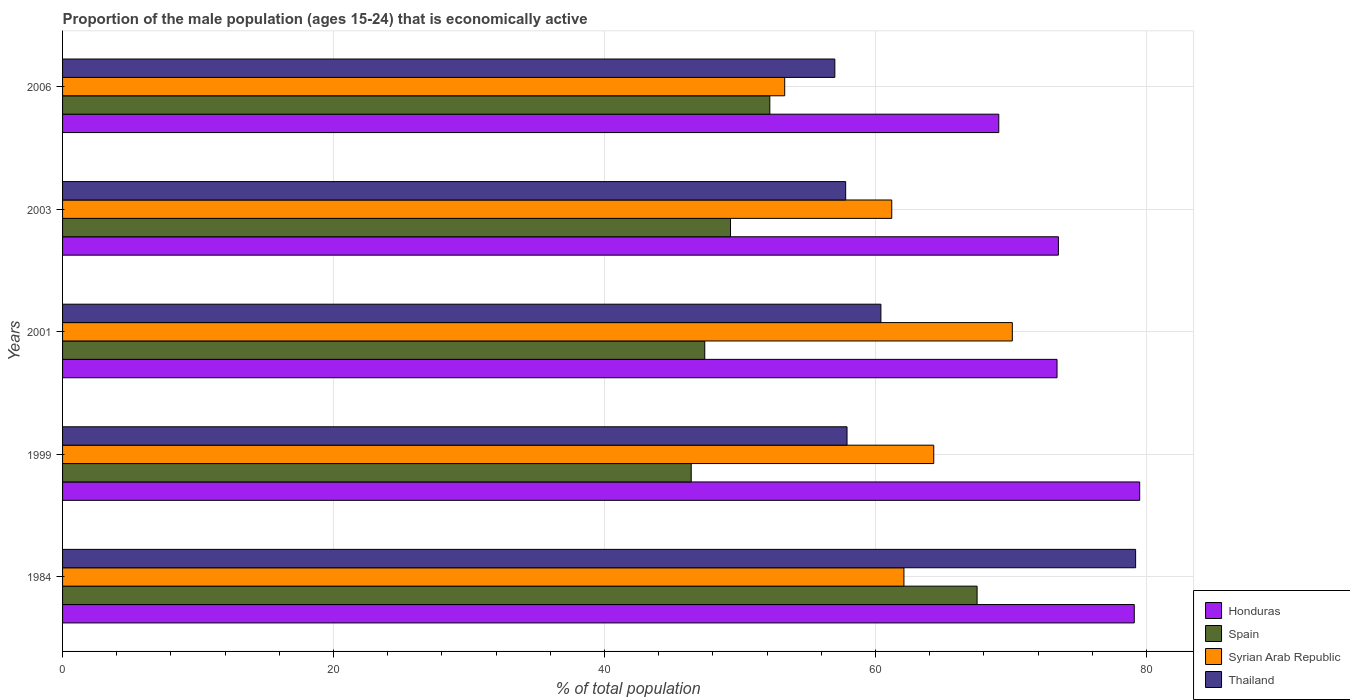Are the number of bars on each tick of the Y-axis equal?
Your response must be concise. Yes. How many bars are there on the 5th tick from the top?
Ensure brevity in your answer.  4. How many bars are there on the 2nd tick from the bottom?
Make the answer very short. 4. What is the label of the 4th group of bars from the top?
Offer a very short reply. 1999. What is the proportion of the male population that is economically active in Spain in 2006?
Ensure brevity in your answer.  52.2. Across all years, what is the maximum proportion of the male population that is economically active in Syrian Arab Republic?
Offer a terse response. 70.1. Across all years, what is the minimum proportion of the male population that is economically active in Honduras?
Offer a terse response. 69.1. What is the total proportion of the male population that is economically active in Honduras in the graph?
Offer a terse response. 374.6. What is the difference between the proportion of the male population that is economically active in Thailand in 2003 and that in 2006?
Keep it short and to the point. 0.8. What is the difference between the proportion of the male population that is economically active in Thailand in 2001 and the proportion of the male population that is economically active in Honduras in 1984?
Provide a succinct answer. -18.7. What is the average proportion of the male population that is economically active in Syrian Arab Republic per year?
Provide a succinct answer. 62.2. In the year 1999, what is the difference between the proportion of the male population that is economically active in Honduras and proportion of the male population that is economically active in Syrian Arab Republic?
Your answer should be very brief. 15.2. In how many years, is the proportion of the male population that is economically active in Honduras greater than 52 %?
Provide a short and direct response. 5. What is the ratio of the proportion of the male population that is economically active in Thailand in 1984 to that in 2006?
Provide a succinct answer. 1.39. Is the proportion of the male population that is economically active in Spain in 1999 less than that in 2001?
Provide a short and direct response. Yes. Is the difference between the proportion of the male population that is economically active in Honduras in 1999 and 2001 greater than the difference between the proportion of the male population that is economically active in Syrian Arab Republic in 1999 and 2001?
Provide a succinct answer. Yes. What is the difference between the highest and the second highest proportion of the male population that is economically active in Spain?
Your response must be concise. 15.3. What is the difference between the highest and the lowest proportion of the male population that is economically active in Honduras?
Your answer should be compact. 10.4. In how many years, is the proportion of the male population that is economically active in Spain greater than the average proportion of the male population that is economically active in Spain taken over all years?
Give a very brief answer. 1. Is the sum of the proportion of the male population that is economically active in Thailand in 1984 and 2001 greater than the maximum proportion of the male population that is economically active in Honduras across all years?
Keep it short and to the point. Yes. Is it the case that in every year, the sum of the proportion of the male population that is economically active in Thailand and proportion of the male population that is economically active in Syrian Arab Republic is greater than the sum of proportion of the male population that is economically active in Spain and proportion of the male population that is economically active in Honduras?
Your answer should be very brief. No. What does the 4th bar from the top in 1999 represents?
Your response must be concise. Honduras. What does the 2nd bar from the bottom in 1999 represents?
Your answer should be very brief. Spain. Is it the case that in every year, the sum of the proportion of the male population that is economically active in Honduras and proportion of the male population that is economically active in Spain is greater than the proportion of the male population that is economically active in Thailand?
Make the answer very short. Yes. How many bars are there?
Provide a short and direct response. 20. How many years are there in the graph?
Make the answer very short. 5. What is the difference between two consecutive major ticks on the X-axis?
Your response must be concise. 20. Are the values on the major ticks of X-axis written in scientific E-notation?
Your response must be concise. No. Does the graph contain any zero values?
Your response must be concise. No. Where does the legend appear in the graph?
Your answer should be compact. Bottom right. How are the legend labels stacked?
Provide a short and direct response. Vertical. What is the title of the graph?
Make the answer very short. Proportion of the male population (ages 15-24) that is economically active. What is the label or title of the X-axis?
Your answer should be compact. % of total population. What is the label or title of the Y-axis?
Offer a terse response. Years. What is the % of total population in Honduras in 1984?
Keep it short and to the point. 79.1. What is the % of total population in Spain in 1984?
Ensure brevity in your answer.  67.5. What is the % of total population in Syrian Arab Republic in 1984?
Your answer should be very brief. 62.1. What is the % of total population of Thailand in 1984?
Your response must be concise. 79.2. What is the % of total population of Honduras in 1999?
Make the answer very short. 79.5. What is the % of total population of Spain in 1999?
Make the answer very short. 46.4. What is the % of total population of Syrian Arab Republic in 1999?
Provide a short and direct response. 64.3. What is the % of total population in Thailand in 1999?
Provide a succinct answer. 57.9. What is the % of total population in Honduras in 2001?
Your response must be concise. 73.4. What is the % of total population in Spain in 2001?
Your answer should be very brief. 47.4. What is the % of total population in Syrian Arab Republic in 2001?
Make the answer very short. 70.1. What is the % of total population in Thailand in 2001?
Make the answer very short. 60.4. What is the % of total population of Honduras in 2003?
Offer a very short reply. 73.5. What is the % of total population in Spain in 2003?
Offer a very short reply. 49.3. What is the % of total population in Syrian Arab Republic in 2003?
Keep it short and to the point. 61.2. What is the % of total population of Thailand in 2003?
Your answer should be compact. 57.8. What is the % of total population of Honduras in 2006?
Your answer should be very brief. 69.1. What is the % of total population of Spain in 2006?
Ensure brevity in your answer.  52.2. What is the % of total population of Syrian Arab Republic in 2006?
Give a very brief answer. 53.3. Across all years, what is the maximum % of total population of Honduras?
Your response must be concise. 79.5. Across all years, what is the maximum % of total population in Spain?
Make the answer very short. 67.5. Across all years, what is the maximum % of total population in Syrian Arab Republic?
Offer a very short reply. 70.1. Across all years, what is the maximum % of total population of Thailand?
Provide a short and direct response. 79.2. Across all years, what is the minimum % of total population in Honduras?
Make the answer very short. 69.1. Across all years, what is the minimum % of total population in Spain?
Your response must be concise. 46.4. Across all years, what is the minimum % of total population in Syrian Arab Republic?
Offer a terse response. 53.3. Across all years, what is the minimum % of total population in Thailand?
Provide a succinct answer. 57. What is the total % of total population in Honduras in the graph?
Your response must be concise. 374.6. What is the total % of total population of Spain in the graph?
Keep it short and to the point. 262.8. What is the total % of total population of Syrian Arab Republic in the graph?
Provide a succinct answer. 311. What is the total % of total population in Thailand in the graph?
Provide a short and direct response. 312.3. What is the difference between the % of total population in Spain in 1984 and that in 1999?
Offer a very short reply. 21.1. What is the difference between the % of total population in Thailand in 1984 and that in 1999?
Offer a terse response. 21.3. What is the difference between the % of total population in Honduras in 1984 and that in 2001?
Provide a short and direct response. 5.7. What is the difference between the % of total population in Spain in 1984 and that in 2001?
Offer a very short reply. 20.1. What is the difference between the % of total population of Syrian Arab Republic in 1984 and that in 2001?
Provide a short and direct response. -8. What is the difference between the % of total population in Thailand in 1984 and that in 2001?
Your answer should be very brief. 18.8. What is the difference between the % of total population of Thailand in 1984 and that in 2003?
Your answer should be compact. 21.4. What is the difference between the % of total population in Honduras in 1984 and that in 2006?
Your answer should be compact. 10. What is the difference between the % of total population of Spain in 1984 and that in 2006?
Your answer should be compact. 15.3. What is the difference between the % of total population of Syrian Arab Republic in 1984 and that in 2006?
Your answer should be very brief. 8.8. What is the difference between the % of total population of Thailand in 1984 and that in 2006?
Your answer should be compact. 22.2. What is the difference between the % of total population of Syrian Arab Republic in 1999 and that in 2001?
Provide a succinct answer. -5.8. What is the difference between the % of total population of Honduras in 1999 and that in 2003?
Offer a very short reply. 6. What is the difference between the % of total population in Spain in 1999 and that in 2003?
Your answer should be very brief. -2.9. What is the difference between the % of total population of Honduras in 1999 and that in 2006?
Provide a short and direct response. 10.4. What is the difference between the % of total population in Syrian Arab Republic in 1999 and that in 2006?
Offer a terse response. 11. What is the difference between the % of total population of Honduras in 2001 and that in 2003?
Ensure brevity in your answer.  -0.1. What is the difference between the % of total population in Thailand in 2001 and that in 2003?
Give a very brief answer. 2.6. What is the difference between the % of total population in Syrian Arab Republic in 2001 and that in 2006?
Offer a terse response. 16.8. What is the difference between the % of total population of Spain in 2003 and that in 2006?
Give a very brief answer. -2.9. What is the difference between the % of total population in Thailand in 2003 and that in 2006?
Offer a terse response. 0.8. What is the difference between the % of total population of Honduras in 1984 and the % of total population of Spain in 1999?
Provide a short and direct response. 32.7. What is the difference between the % of total population in Honduras in 1984 and the % of total population in Thailand in 1999?
Keep it short and to the point. 21.2. What is the difference between the % of total population in Spain in 1984 and the % of total population in Syrian Arab Republic in 1999?
Your answer should be very brief. 3.2. What is the difference between the % of total population in Syrian Arab Republic in 1984 and the % of total population in Thailand in 1999?
Give a very brief answer. 4.2. What is the difference between the % of total population of Honduras in 1984 and the % of total population of Spain in 2001?
Offer a very short reply. 31.7. What is the difference between the % of total population in Spain in 1984 and the % of total population in Thailand in 2001?
Your response must be concise. 7.1. What is the difference between the % of total population of Honduras in 1984 and the % of total population of Spain in 2003?
Your answer should be compact. 29.8. What is the difference between the % of total population of Honduras in 1984 and the % of total population of Thailand in 2003?
Your answer should be compact. 21.3. What is the difference between the % of total population in Spain in 1984 and the % of total population in Syrian Arab Republic in 2003?
Keep it short and to the point. 6.3. What is the difference between the % of total population of Spain in 1984 and the % of total population of Thailand in 2003?
Keep it short and to the point. 9.7. What is the difference between the % of total population of Honduras in 1984 and the % of total population of Spain in 2006?
Provide a short and direct response. 26.9. What is the difference between the % of total population of Honduras in 1984 and the % of total population of Syrian Arab Republic in 2006?
Provide a short and direct response. 25.8. What is the difference between the % of total population of Honduras in 1984 and the % of total population of Thailand in 2006?
Provide a succinct answer. 22.1. What is the difference between the % of total population of Spain in 1984 and the % of total population of Thailand in 2006?
Offer a terse response. 10.5. What is the difference between the % of total population in Syrian Arab Republic in 1984 and the % of total population in Thailand in 2006?
Your answer should be compact. 5.1. What is the difference between the % of total population in Honduras in 1999 and the % of total population in Spain in 2001?
Your answer should be very brief. 32.1. What is the difference between the % of total population in Honduras in 1999 and the % of total population in Syrian Arab Republic in 2001?
Give a very brief answer. 9.4. What is the difference between the % of total population of Spain in 1999 and the % of total population of Syrian Arab Republic in 2001?
Keep it short and to the point. -23.7. What is the difference between the % of total population in Syrian Arab Republic in 1999 and the % of total population in Thailand in 2001?
Make the answer very short. 3.9. What is the difference between the % of total population of Honduras in 1999 and the % of total population of Spain in 2003?
Offer a very short reply. 30.2. What is the difference between the % of total population of Honduras in 1999 and the % of total population of Thailand in 2003?
Your response must be concise. 21.7. What is the difference between the % of total population in Spain in 1999 and the % of total population in Syrian Arab Republic in 2003?
Make the answer very short. -14.8. What is the difference between the % of total population of Honduras in 1999 and the % of total population of Spain in 2006?
Provide a succinct answer. 27.3. What is the difference between the % of total population of Honduras in 1999 and the % of total population of Syrian Arab Republic in 2006?
Ensure brevity in your answer.  26.2. What is the difference between the % of total population of Honduras in 1999 and the % of total population of Thailand in 2006?
Ensure brevity in your answer.  22.5. What is the difference between the % of total population in Spain in 1999 and the % of total population in Syrian Arab Republic in 2006?
Provide a short and direct response. -6.9. What is the difference between the % of total population in Honduras in 2001 and the % of total population in Spain in 2003?
Offer a terse response. 24.1. What is the difference between the % of total population in Honduras in 2001 and the % of total population in Syrian Arab Republic in 2003?
Provide a succinct answer. 12.2. What is the difference between the % of total population in Honduras in 2001 and the % of total population in Spain in 2006?
Give a very brief answer. 21.2. What is the difference between the % of total population of Honduras in 2001 and the % of total population of Syrian Arab Republic in 2006?
Ensure brevity in your answer.  20.1. What is the difference between the % of total population in Spain in 2001 and the % of total population in Syrian Arab Republic in 2006?
Ensure brevity in your answer.  -5.9. What is the difference between the % of total population of Spain in 2001 and the % of total population of Thailand in 2006?
Offer a terse response. -9.6. What is the difference between the % of total population of Syrian Arab Republic in 2001 and the % of total population of Thailand in 2006?
Your answer should be compact. 13.1. What is the difference between the % of total population of Honduras in 2003 and the % of total population of Spain in 2006?
Ensure brevity in your answer.  21.3. What is the difference between the % of total population in Honduras in 2003 and the % of total population in Syrian Arab Republic in 2006?
Make the answer very short. 20.2. What is the difference between the % of total population of Honduras in 2003 and the % of total population of Thailand in 2006?
Give a very brief answer. 16.5. What is the difference between the % of total population in Spain in 2003 and the % of total population in Syrian Arab Republic in 2006?
Offer a very short reply. -4. What is the difference between the % of total population in Syrian Arab Republic in 2003 and the % of total population in Thailand in 2006?
Your answer should be compact. 4.2. What is the average % of total population in Honduras per year?
Your response must be concise. 74.92. What is the average % of total population of Spain per year?
Provide a short and direct response. 52.56. What is the average % of total population in Syrian Arab Republic per year?
Give a very brief answer. 62.2. What is the average % of total population of Thailand per year?
Give a very brief answer. 62.46. In the year 1984, what is the difference between the % of total population of Honduras and % of total population of Thailand?
Provide a short and direct response. -0.1. In the year 1984, what is the difference between the % of total population in Spain and % of total population in Thailand?
Offer a terse response. -11.7. In the year 1984, what is the difference between the % of total population of Syrian Arab Republic and % of total population of Thailand?
Make the answer very short. -17.1. In the year 1999, what is the difference between the % of total population in Honduras and % of total population in Spain?
Provide a short and direct response. 33.1. In the year 1999, what is the difference between the % of total population of Honduras and % of total population of Syrian Arab Republic?
Offer a very short reply. 15.2. In the year 1999, what is the difference between the % of total population in Honduras and % of total population in Thailand?
Offer a terse response. 21.6. In the year 1999, what is the difference between the % of total population in Spain and % of total population in Syrian Arab Republic?
Keep it short and to the point. -17.9. In the year 1999, what is the difference between the % of total population in Syrian Arab Republic and % of total population in Thailand?
Provide a short and direct response. 6.4. In the year 2001, what is the difference between the % of total population of Honduras and % of total population of Spain?
Give a very brief answer. 26. In the year 2001, what is the difference between the % of total population of Honduras and % of total population of Syrian Arab Republic?
Provide a short and direct response. 3.3. In the year 2001, what is the difference between the % of total population in Spain and % of total population in Syrian Arab Republic?
Offer a terse response. -22.7. In the year 2003, what is the difference between the % of total population in Honduras and % of total population in Spain?
Your answer should be compact. 24.2. In the year 2003, what is the difference between the % of total population of Honduras and % of total population of Thailand?
Give a very brief answer. 15.7. In the year 2003, what is the difference between the % of total population in Spain and % of total population in Thailand?
Your answer should be compact. -8.5. In the year 2003, what is the difference between the % of total population in Syrian Arab Republic and % of total population in Thailand?
Make the answer very short. 3.4. In the year 2006, what is the difference between the % of total population in Honduras and % of total population in Spain?
Provide a succinct answer. 16.9. In the year 2006, what is the difference between the % of total population in Honduras and % of total population in Syrian Arab Republic?
Give a very brief answer. 15.8. In the year 2006, what is the difference between the % of total population of Honduras and % of total population of Thailand?
Your answer should be very brief. 12.1. In the year 2006, what is the difference between the % of total population of Spain and % of total population of Syrian Arab Republic?
Your response must be concise. -1.1. In the year 2006, what is the difference between the % of total population of Spain and % of total population of Thailand?
Your response must be concise. -4.8. In the year 2006, what is the difference between the % of total population of Syrian Arab Republic and % of total population of Thailand?
Your answer should be very brief. -3.7. What is the ratio of the % of total population of Spain in 1984 to that in 1999?
Offer a very short reply. 1.45. What is the ratio of the % of total population in Syrian Arab Republic in 1984 to that in 1999?
Offer a terse response. 0.97. What is the ratio of the % of total population in Thailand in 1984 to that in 1999?
Make the answer very short. 1.37. What is the ratio of the % of total population of Honduras in 1984 to that in 2001?
Ensure brevity in your answer.  1.08. What is the ratio of the % of total population in Spain in 1984 to that in 2001?
Your answer should be very brief. 1.42. What is the ratio of the % of total population in Syrian Arab Republic in 1984 to that in 2001?
Offer a terse response. 0.89. What is the ratio of the % of total population in Thailand in 1984 to that in 2001?
Your answer should be compact. 1.31. What is the ratio of the % of total population in Honduras in 1984 to that in 2003?
Your response must be concise. 1.08. What is the ratio of the % of total population in Spain in 1984 to that in 2003?
Your answer should be compact. 1.37. What is the ratio of the % of total population in Syrian Arab Republic in 1984 to that in 2003?
Keep it short and to the point. 1.01. What is the ratio of the % of total population of Thailand in 1984 to that in 2003?
Keep it short and to the point. 1.37. What is the ratio of the % of total population in Honduras in 1984 to that in 2006?
Your answer should be compact. 1.14. What is the ratio of the % of total population in Spain in 1984 to that in 2006?
Provide a succinct answer. 1.29. What is the ratio of the % of total population of Syrian Arab Republic in 1984 to that in 2006?
Ensure brevity in your answer.  1.17. What is the ratio of the % of total population in Thailand in 1984 to that in 2006?
Your response must be concise. 1.39. What is the ratio of the % of total population in Honduras in 1999 to that in 2001?
Your answer should be compact. 1.08. What is the ratio of the % of total population of Spain in 1999 to that in 2001?
Keep it short and to the point. 0.98. What is the ratio of the % of total population in Syrian Arab Republic in 1999 to that in 2001?
Offer a terse response. 0.92. What is the ratio of the % of total population of Thailand in 1999 to that in 2001?
Make the answer very short. 0.96. What is the ratio of the % of total population in Honduras in 1999 to that in 2003?
Ensure brevity in your answer.  1.08. What is the ratio of the % of total population of Syrian Arab Republic in 1999 to that in 2003?
Keep it short and to the point. 1.05. What is the ratio of the % of total population in Honduras in 1999 to that in 2006?
Provide a succinct answer. 1.15. What is the ratio of the % of total population of Syrian Arab Republic in 1999 to that in 2006?
Offer a very short reply. 1.21. What is the ratio of the % of total population of Thailand in 1999 to that in 2006?
Provide a short and direct response. 1.02. What is the ratio of the % of total population of Honduras in 2001 to that in 2003?
Ensure brevity in your answer.  1. What is the ratio of the % of total population in Spain in 2001 to that in 2003?
Keep it short and to the point. 0.96. What is the ratio of the % of total population of Syrian Arab Republic in 2001 to that in 2003?
Your answer should be compact. 1.15. What is the ratio of the % of total population in Thailand in 2001 to that in 2003?
Offer a terse response. 1.04. What is the ratio of the % of total population in Honduras in 2001 to that in 2006?
Offer a very short reply. 1.06. What is the ratio of the % of total population of Spain in 2001 to that in 2006?
Keep it short and to the point. 0.91. What is the ratio of the % of total population of Syrian Arab Republic in 2001 to that in 2006?
Give a very brief answer. 1.32. What is the ratio of the % of total population of Thailand in 2001 to that in 2006?
Your answer should be very brief. 1.06. What is the ratio of the % of total population in Honduras in 2003 to that in 2006?
Your response must be concise. 1.06. What is the ratio of the % of total population in Spain in 2003 to that in 2006?
Give a very brief answer. 0.94. What is the ratio of the % of total population of Syrian Arab Republic in 2003 to that in 2006?
Offer a very short reply. 1.15. What is the difference between the highest and the second highest % of total population of Honduras?
Provide a short and direct response. 0.4. What is the difference between the highest and the second highest % of total population of Syrian Arab Republic?
Ensure brevity in your answer.  5.8. What is the difference between the highest and the lowest % of total population of Spain?
Give a very brief answer. 21.1. 